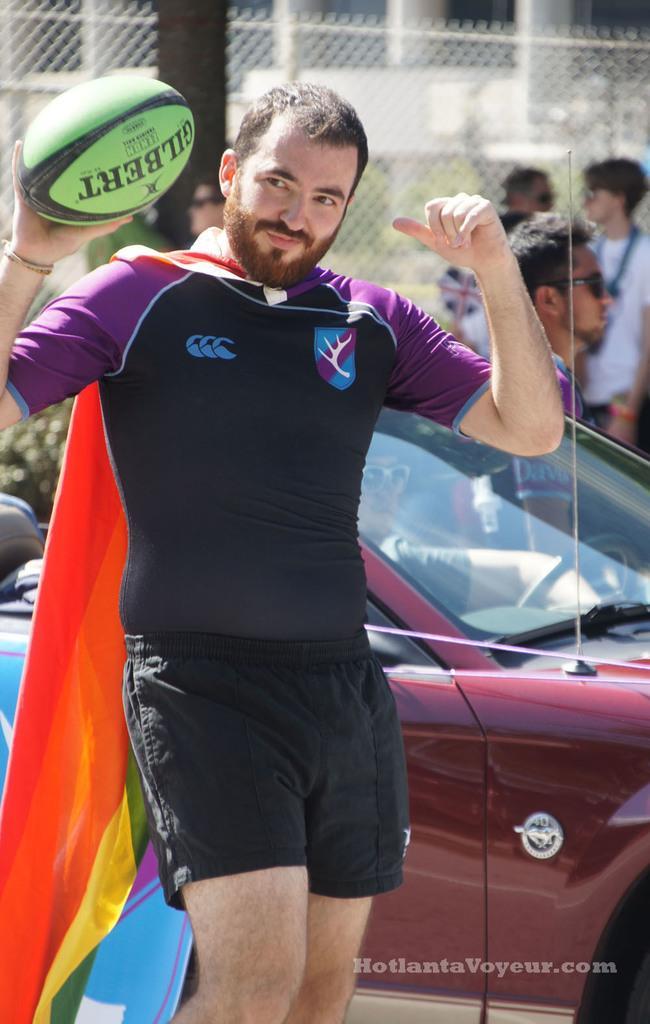Please provide a concise description of this image. There is a man standing and holding a ball in his hand at the background there is a car, group of people and a tree. 